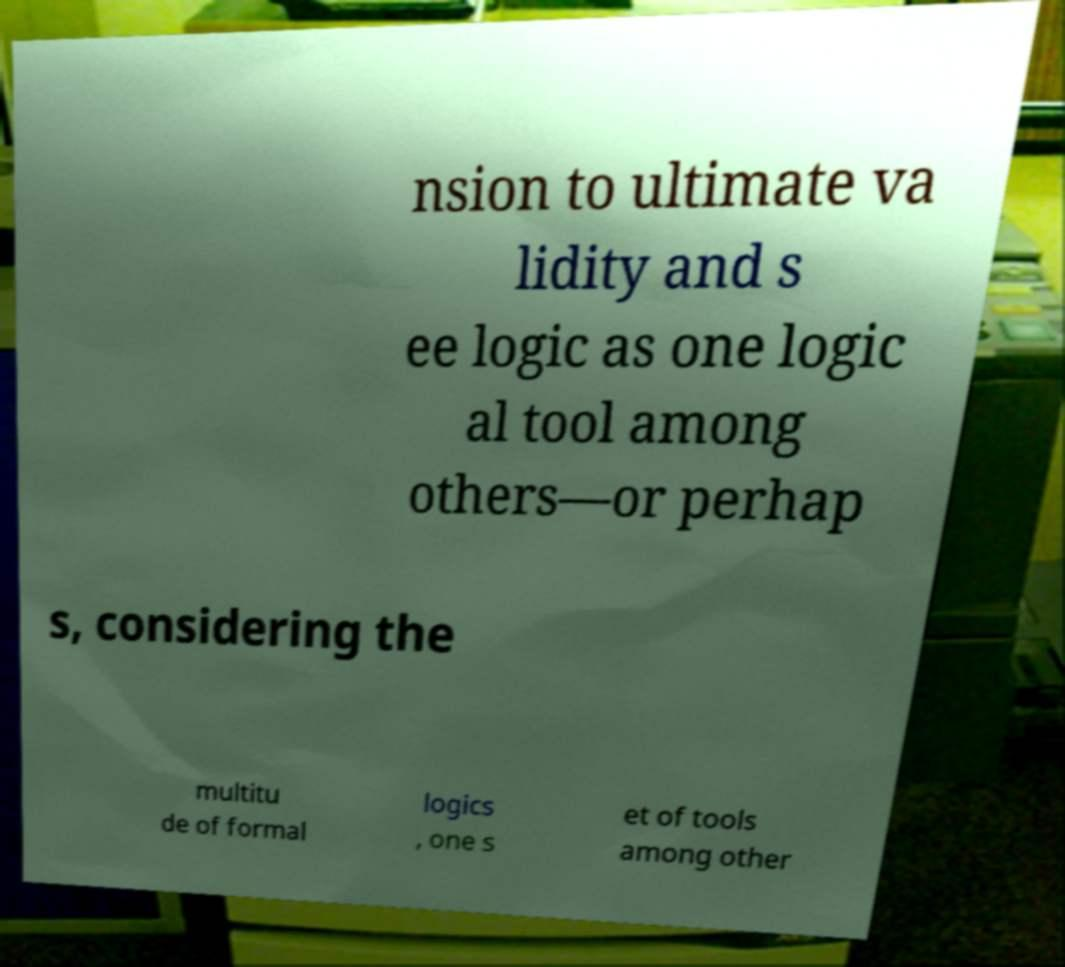Can you accurately transcribe the text from the provided image for me? nsion to ultimate va lidity and s ee logic as one logic al tool among others—or perhap s, considering the multitu de of formal logics , one s et of tools among other 